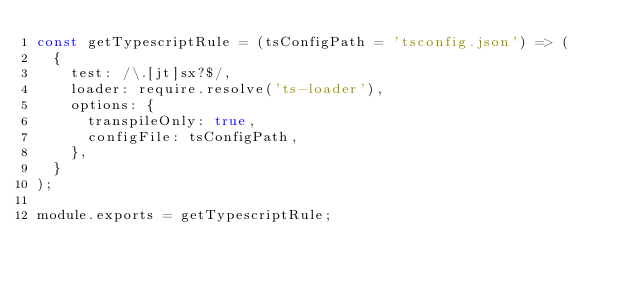Convert code to text. <code><loc_0><loc_0><loc_500><loc_500><_JavaScript_>const getTypescriptRule = (tsConfigPath = 'tsconfig.json') => (
  {
    test: /\.[jt]sx?$/,
    loader: require.resolve('ts-loader'),
    options: {
      transpileOnly: true,
      configFile: tsConfigPath,
    },
  }
);

module.exports = getTypescriptRule;
</code> 